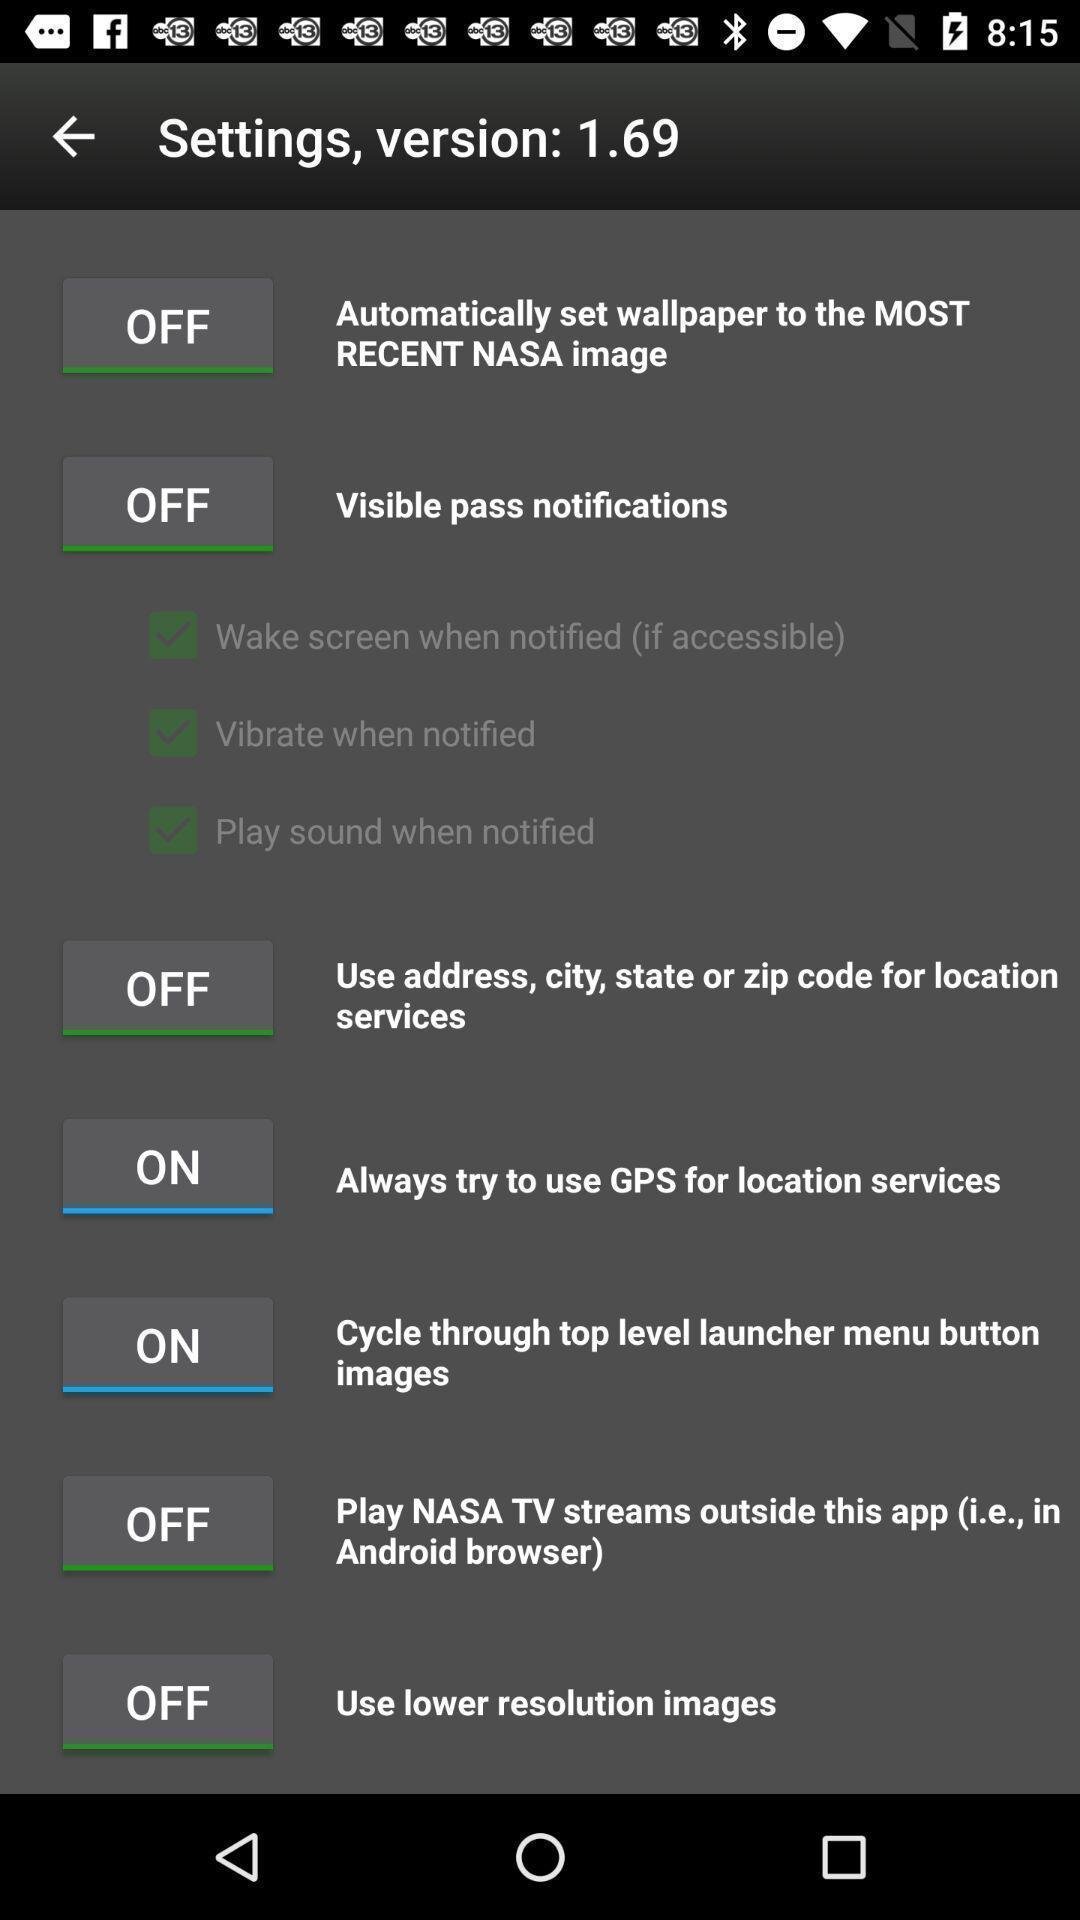Describe this image in words. Settings page displayed. 